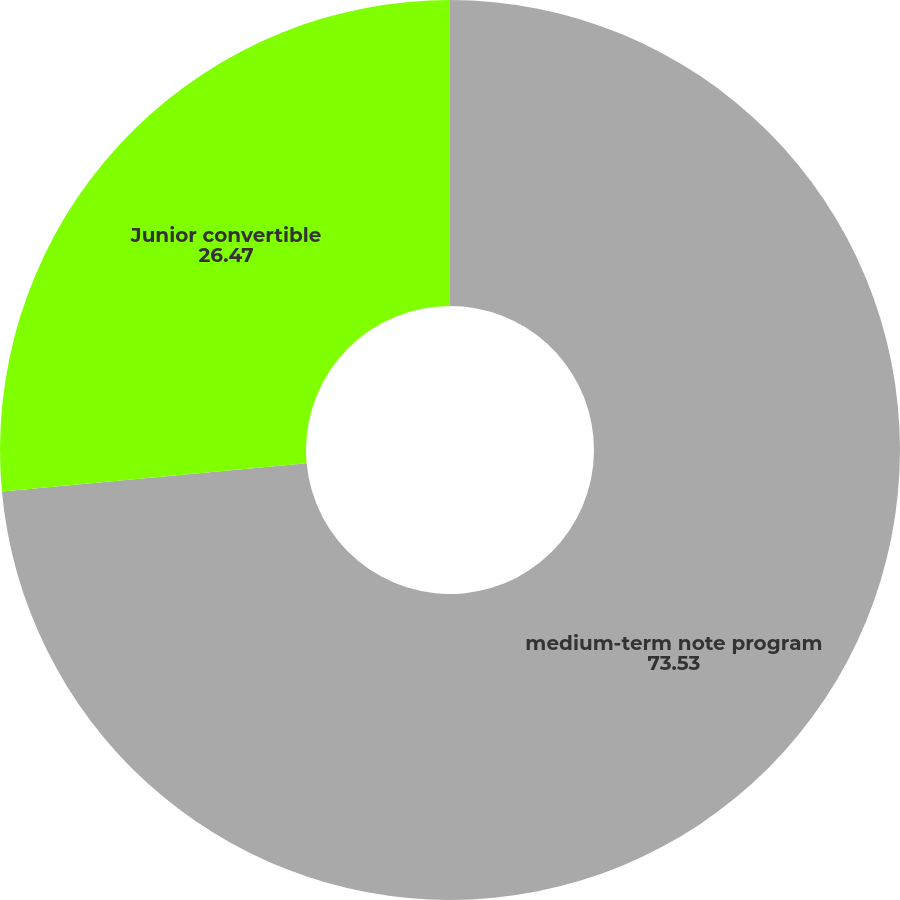Convert chart. <chart><loc_0><loc_0><loc_500><loc_500><pie_chart><fcel>medium-term note program<fcel>Junior convertible<nl><fcel>73.53%<fcel>26.47%<nl></chart> 